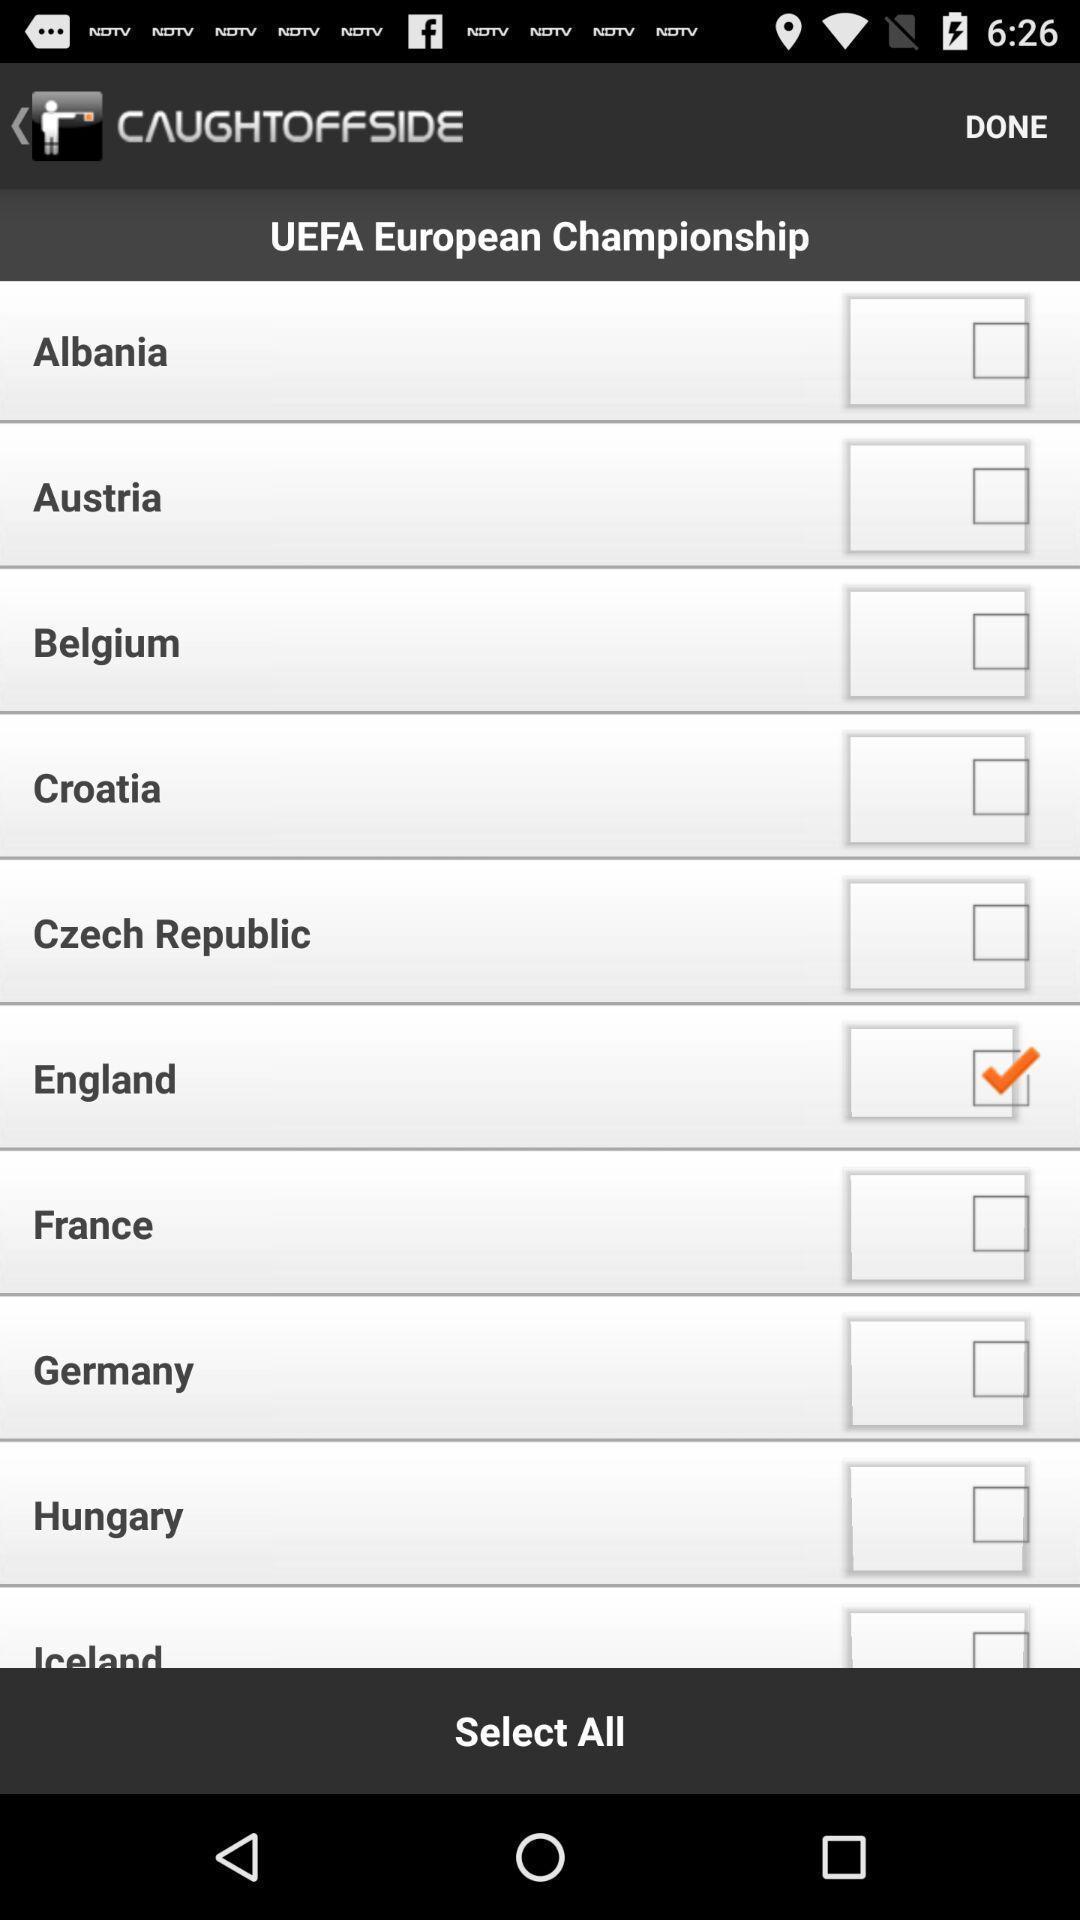Describe the content in this image. Screen shows to select list of checkboxes. 